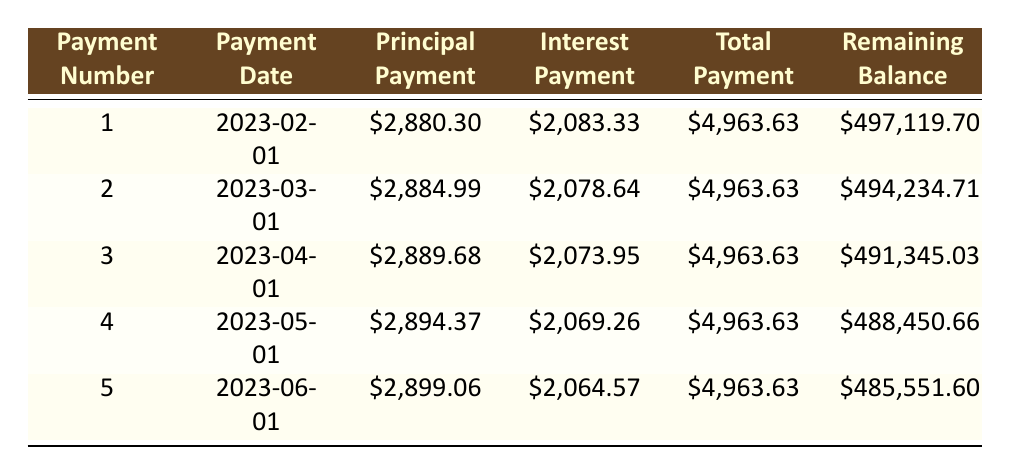What is the total payment for the first installment? The total payment for the first installment can be found in the column under "Total Payment" for payment number 1, which states \$4,963.63.
Answer: 4,963.63 What is the principal payment for the third installment? The principal payment for the third installment is listed under "Principal Payment" for payment number 3, which is \$2,889.68.
Answer: 2,889.68 What is the remaining balance after the fifth payment? The remaining balance after the fifth payment can be found in the last row of the "Remaining Balance" column for payment number 5, which is \$485,551.60.
Answer: 485,551.60 What is the total interest paid in the first quarter (first three payments)? To calculate total interest for the first quarter, sum the interest payments for the first three payments: \$2,083.33 + \$2,078.64 + \$2,073.95 = \$6,235.92.
Answer: 6,235.92 Is the interest payment for the second installment greater than that for the first installment? The interest payment for the second installment is \$2,078.64 and for the first installment is \$2,083.33. Since \$2,078.64 is less than \$2,083.33, the statement is false.
Answer: No What is the average principal payment over the first five installments? To find the average principal payment, sum the principal payments for the first five payments: \$2,880.30 + \$2,884.99 + \$2,889.68 + \$2,894.37 + \$2,899.06 = \$14,448.40. Then divide by the number of payments (5). The average is \$14,448.40 / 5 = \$2,889.68.
Answer: 2,889.68 What is the increase in principal payment from the first payment to the fifth payment? The principal payment for the first payment is \$2,880.30 and for the fifth payment is \$2,899.06. The increase can be calculated as \$2,899.06 - \$2,880.30 = \$18.76.
Answer: 18.76 Is the total payment consistent for the first five months? The total payment for all five months is \$4,963.63, which remains constant across all entries in the "Total Payment" column, confirming consistency.
Answer: Yes What is the total amount paid towards principal after the first four payments? To find the total amount paid towards principal after the first four payments, sum the principal payments: \$2,880.30 + \$2,884.99 + \$2,889.68 + \$2,894.37 = \$11,649.34.
Answer: 11,649.34 